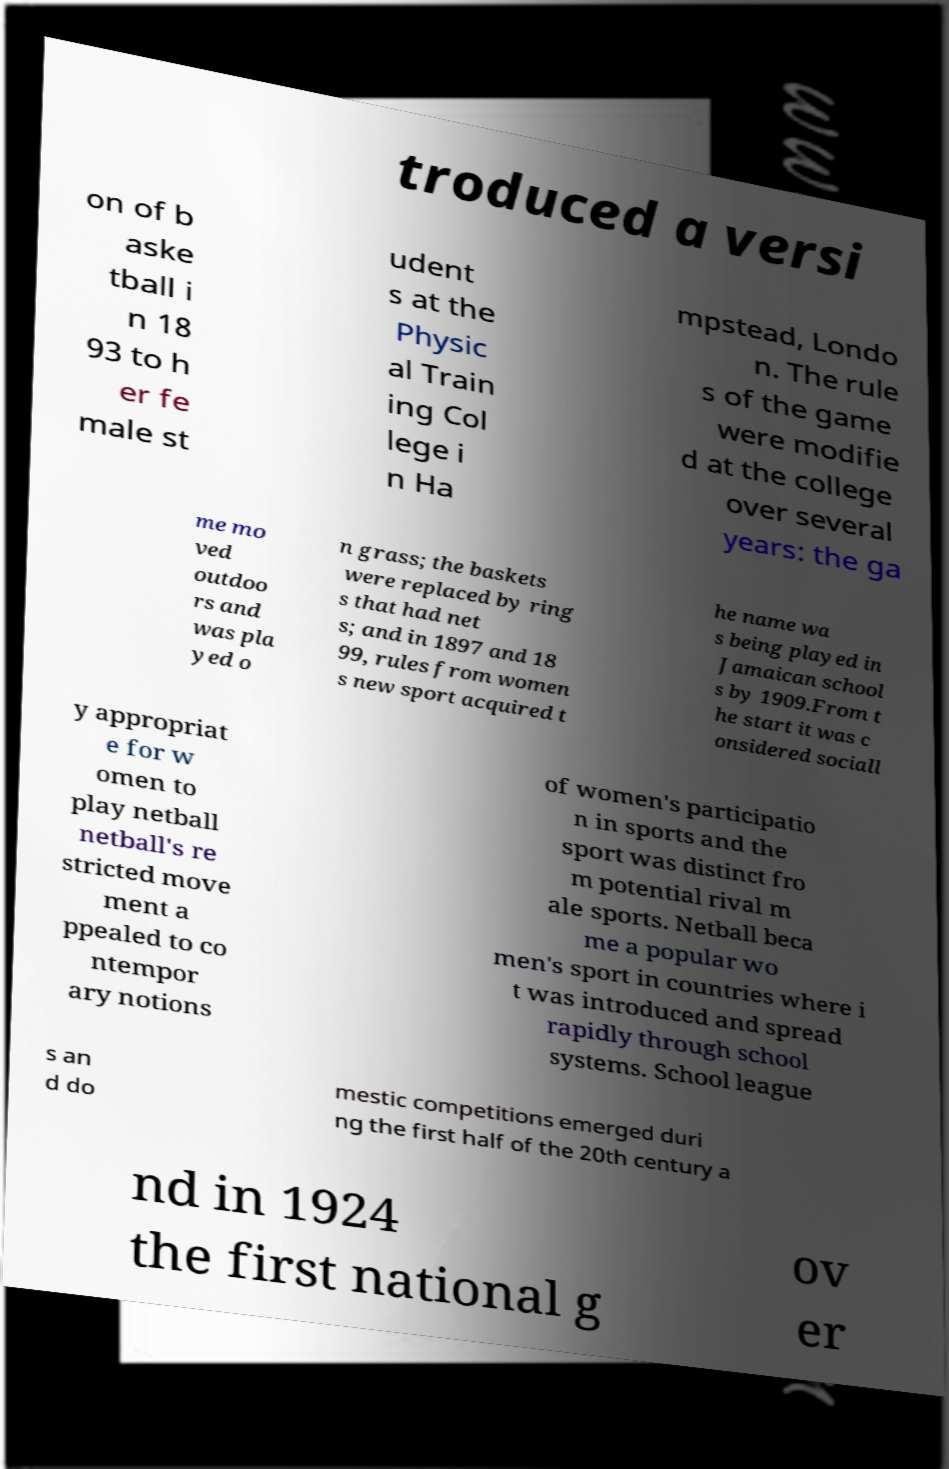I need the written content from this picture converted into text. Can you do that? troduced a versi on of b aske tball i n 18 93 to h er fe male st udent s at the Physic al Train ing Col lege i n Ha mpstead, Londo n. The rule s of the game were modifie d at the college over several years: the ga me mo ved outdoo rs and was pla yed o n grass; the baskets were replaced by ring s that had net s; and in 1897 and 18 99, rules from women s new sport acquired t he name wa s being played in Jamaican school s by 1909.From t he start it was c onsidered sociall y appropriat e for w omen to play netball netball's re stricted move ment a ppealed to co ntempor ary notions of women's participatio n in sports and the sport was distinct fro m potential rival m ale sports. Netball beca me a popular wo men's sport in countries where i t was introduced and spread rapidly through school systems. School league s an d do mestic competitions emerged duri ng the first half of the 20th century a nd in 1924 the first national g ov er 